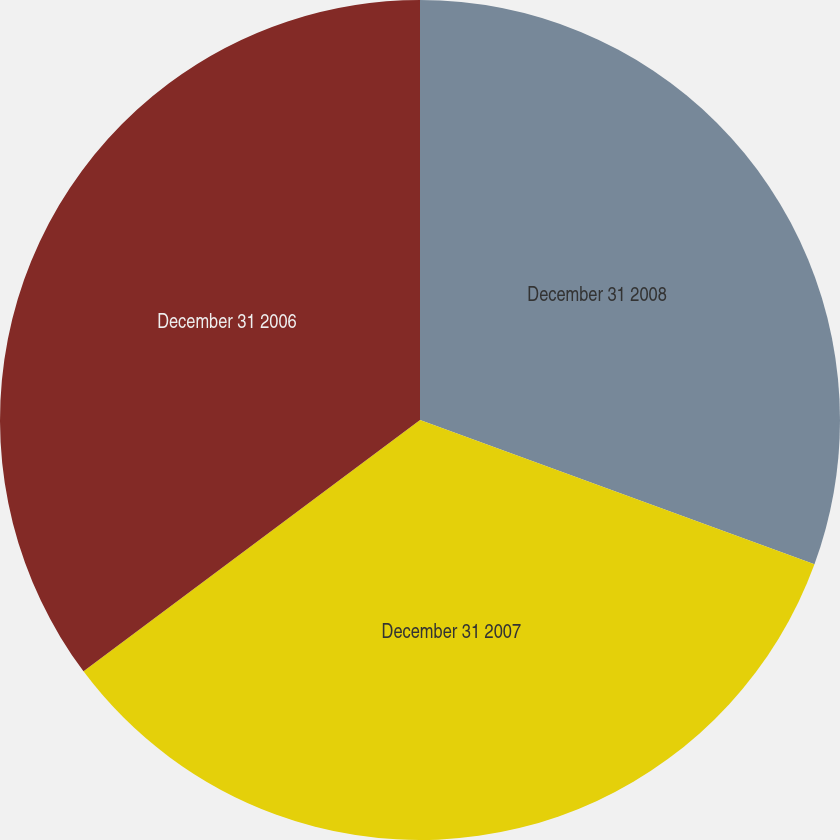Convert chart. <chart><loc_0><loc_0><loc_500><loc_500><pie_chart><fcel>December 31 2008<fcel>December 31 2007<fcel>December 31 2006<nl><fcel>30.58%<fcel>34.21%<fcel>35.21%<nl></chart> 